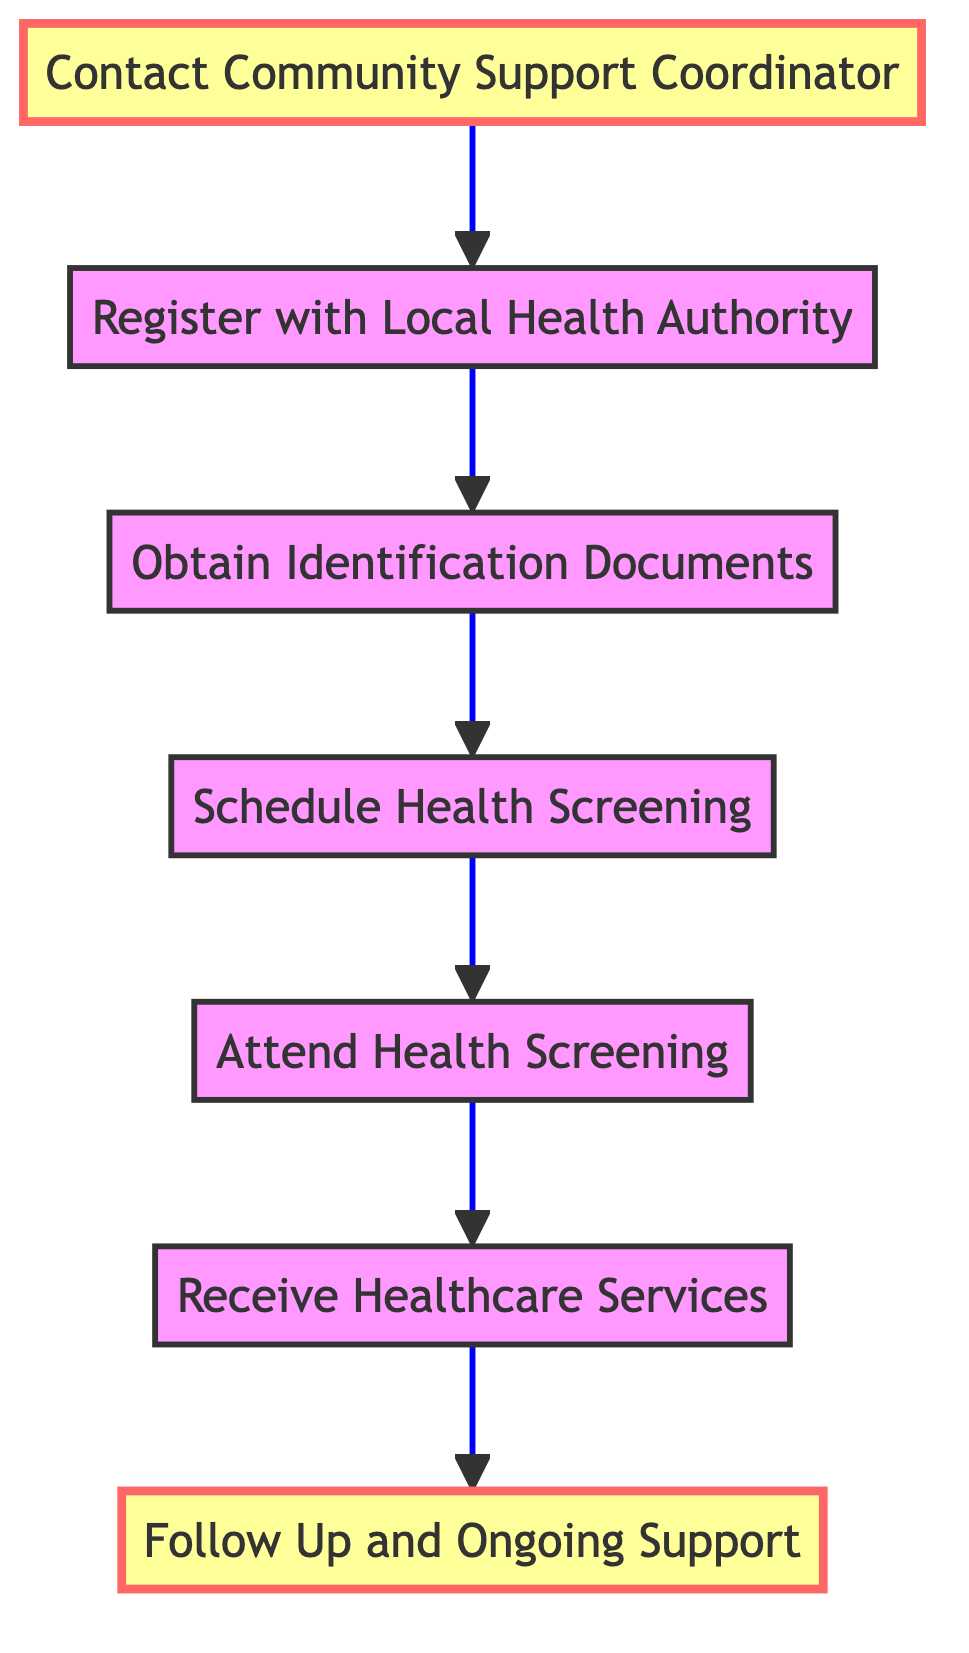What is the first step in the flow chart? The first step is "Contact Community Support Coordinator". This can be determined by observing the direction of the flow in the diagram, which begins at the bottom node and follows up to the top.
Answer: Contact Community Support Coordinator How many total steps are in the flow chart? By counting the nodes present in the diagram, we find there are seven distinct steps leading from initial contact to ongoing support.
Answer: 7 Which step follows "Schedule Health Screening"? The step that follows "Schedule Health Screening" is "Attend Health Screening". The arrows between the steps depict the sequence of actions in the flow chart.
Answer: Attend Health Screening What is the last step in the process? The last step in the process is "Follow Up and Ongoing Support". This is identified as the topmost step in the flow, indicating it is the final action to be taken.
Answer: Follow Up and Ongoing Support Which two steps are highlighted in the diagram? The two highlighted steps in the diagram are "Contact Community Support Coordinator" and "Follow Up and Ongoing Support". These are indicated visually by their distinct color fill, denoting importance.
Answer: Contact Community Support Coordinator, Follow Up and Ongoing Support What must be done before receiving healthcare services? Before receiving healthcare services, one must "Attend Health Screening". This step is essential as it identifies medical needs that inform the subsequent healthcare access.
Answer: Attend Health Screening Which step comes immediately after obtaining identification documents? The step that comes immediately after "Obtain Identification Documents" is "Schedule Health Screening". The flow follows a direct progression in the diagram from obtaining documents to scheduling an appointment.
Answer: Schedule Health Screening Explain the flow from "Register with Local Health Authority" to the last step. Starting from "Register with Local Health Authority", the flow continues to "Obtain Identification Documents" next. After that, it proceeds to "Schedule Health Screening", then to "Attend Health Screening". Following that, it moves on to "Receive Healthcare Services", and finally culminates at "Follow Up and Ongoing Support". This illustrates a sequence necessary to fully address healthcare access for refugee children.
Answer: Follow Up and Ongoing Support 